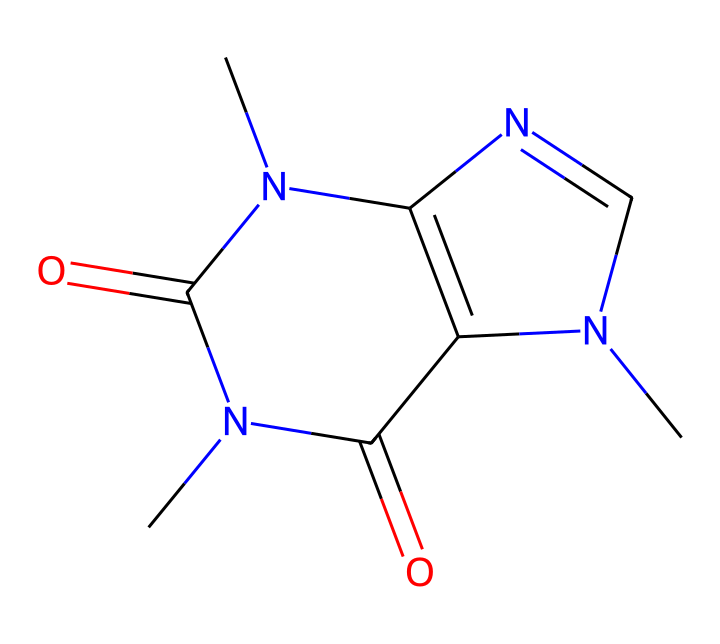how many nitrogen atoms are in the caffeine structure? By examining the SMILES representation, we can identify each nitrogen atom (N). Counting the nitrogen atoms present, we find there are four nitrogen atoms in the structure.
Answer: four what type of chemical is caffeine? Caffeine is classified as an alkaloid, which is a class of naturally occurring organic compounds that mostly contain basic nitrogen atoms. The presence of nitrogen in the structure indicates it belongs to this class.
Answer: alkaloid how many carbon atoms are present in caffeine? In the SMILES representation, we can count the carbon atoms (C). There are eight carbon atoms in the structure.
Answer: eight what is the total number of rings in the caffeine structure? The SMILES provides information about the cyclic structure, where numbers indicate the start and end of rings. By analyzing, we observe that caffeine contains two distinct rings.
Answer: two which part of caffeine contributes to its stimulant effect? The nitrogen atoms in the caffeine structure are responsible for its stimulant properties, as they interact with neurotransmitter receptors in the brain, enhancing alertness and reducing fatigue.
Answer: nitrogen atoms what functional groups are identified in the caffeine structure? Analyzing the SMILES representation, we observe that caffeine contains both amine groups and carbonyl groups (indicated by the presence of N and C=O). These functional groups contribute to its chemical behavior and properties.
Answer: amine and carbonyl 